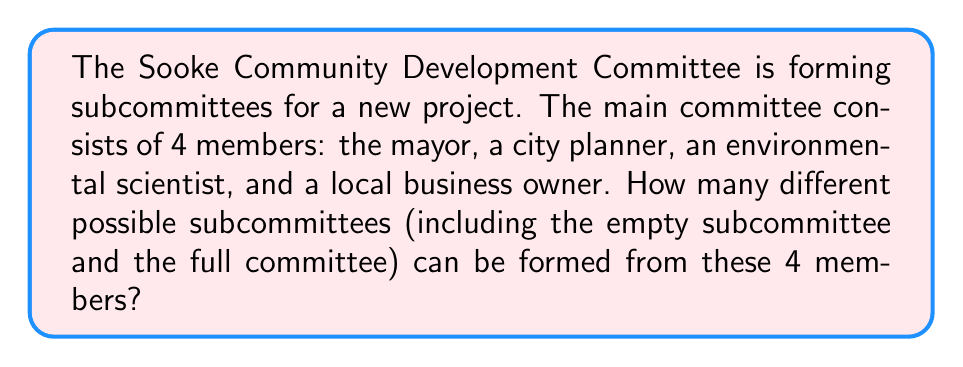What is the answer to this math problem? To solve this problem, we need to apply the concept of power sets. The power set of a set S is the set of all possible subsets of S, including the empty set and S itself.

Let's approach this step-by-step:

1) First, let's define our set:
   S = {mayor, city planner, environmental scientist, business owner}

2) The number of elements in S is 4.

3) For a set with n elements, the number of elements in its power set is given by the formula:
   $$ 2^n $$

4) This is because for each element, we have two choices: either include it in a subset or not.

5) In our case, n = 4, so the number of subcommittees is:
   $$ 2^4 = 16 $$

6) We can verify this by listing all possible subcommittees:
   - Empty subcommittee: {}
   - 4 subcommittees with 1 member: {mayor}, {city planner}, {environmental scientist}, {business owner}
   - 6 subcommittees with 2 members: {mayor, city planner}, {mayor, environmental scientist}, {mayor, business owner}, {city planner, environmental scientist}, {city planner, business owner}, {environmental scientist, business owner}
   - 4 subcommittees with 3 members: {mayor, city planner, environmental scientist}, {mayor, city planner, business owner}, {mayor, environmental scientist, business owner}, {city planner, environmental scientist, business owner}
   - Full committee: {mayor, city planner, environmental scientist, business owner}

Indeed, 1 + 4 + 6 + 4 + 1 = 16

Therefore, there are 16 possible subcommittees that can be formed.
Answer: $$ 2^4 = 16 $$ possible subcommittees 